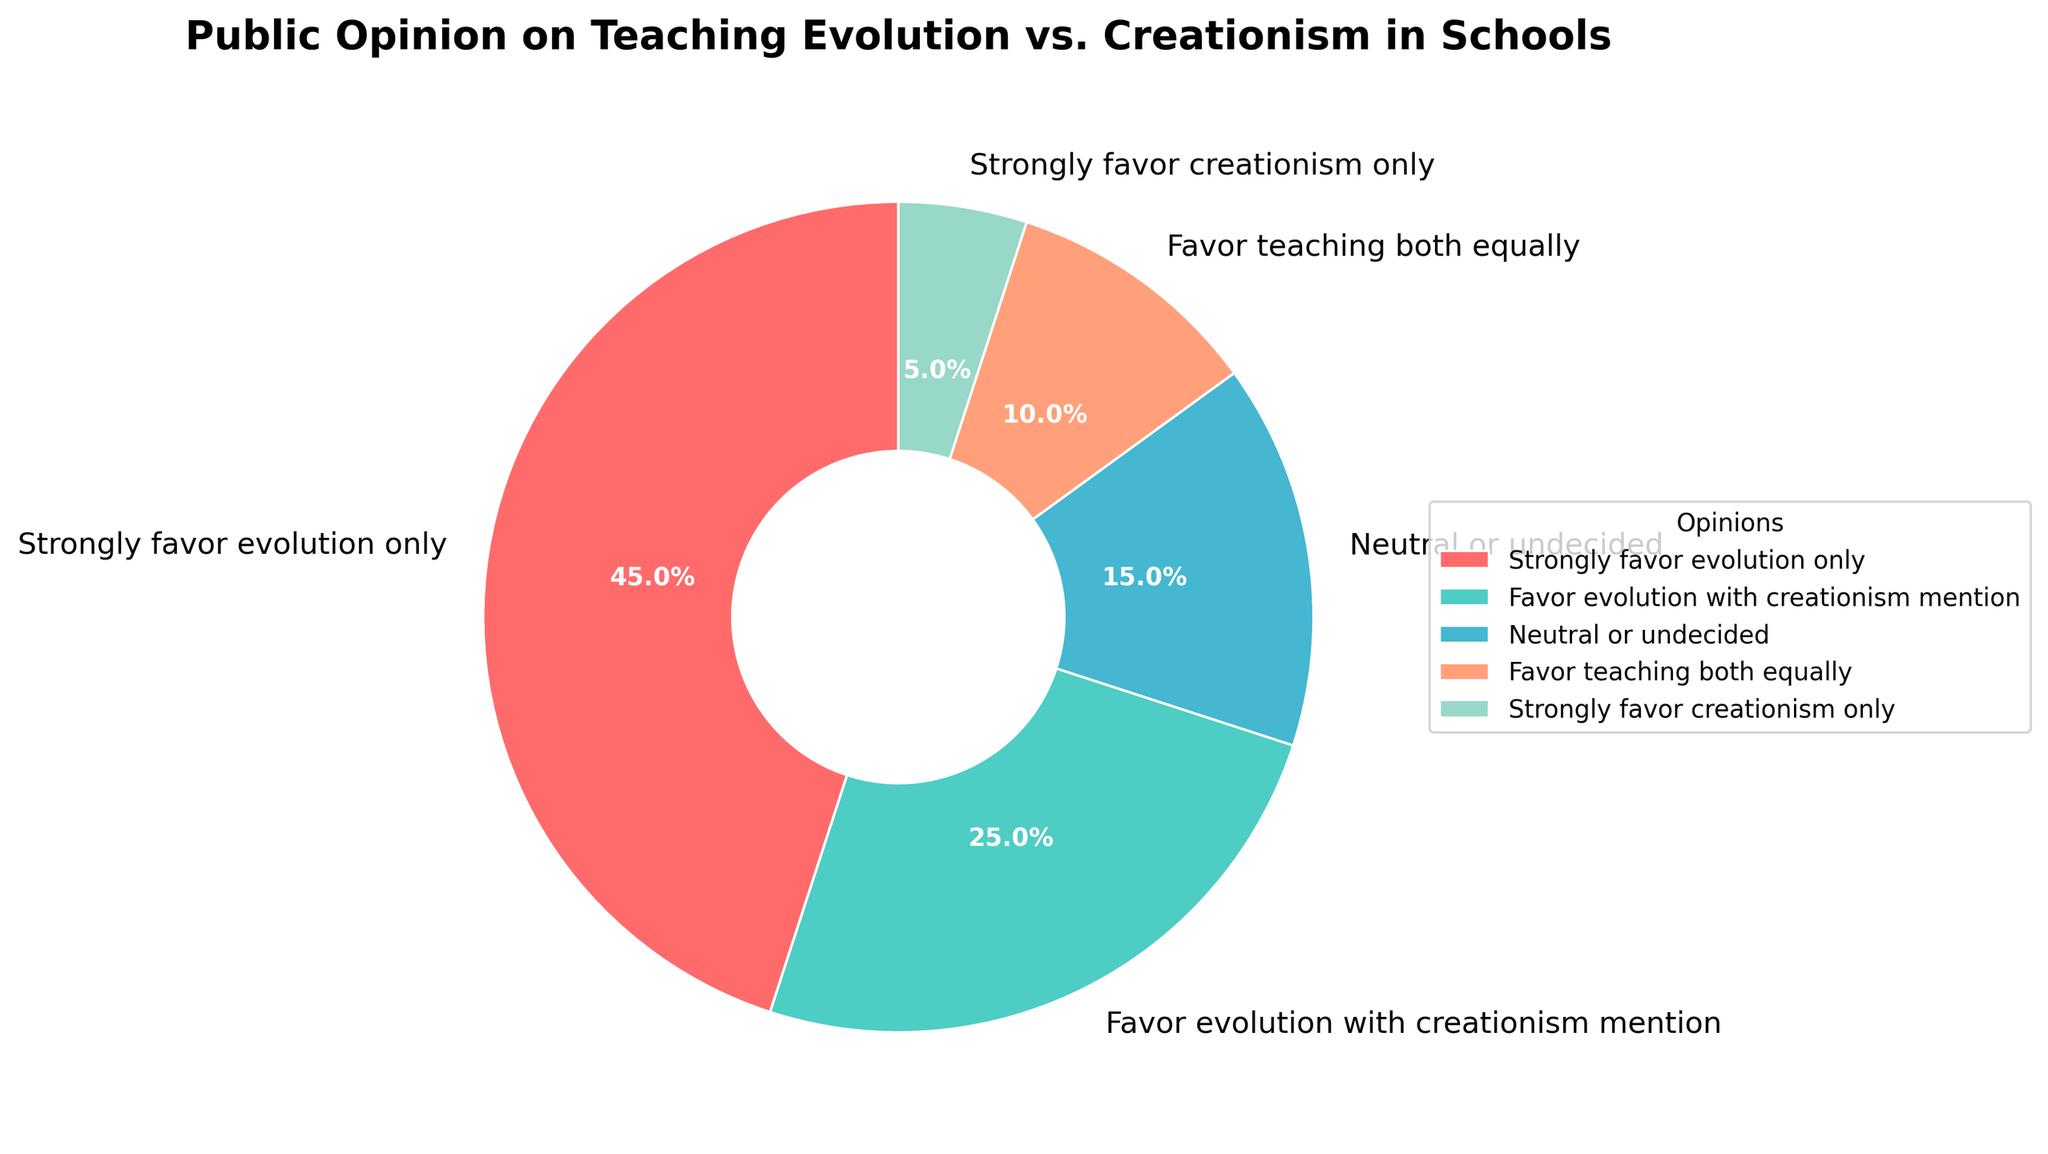What's the most strongly favored opinion on teaching evolution vs. creationism in schools? The slice representing "Strongly favor evolution only" is the largest in the pie chart, indicating it has the highest percentage.
Answer: Strongly favor evolution only Which opinions are least favored by the public? The pie chart shows that the smallest slice is "Strongly favor creationism only" at 5%.
Answer: Strongly favor creationism only What percentage favors both perspectives equally? Observing the chart, the slice labeled "Favor teaching both equally" is identified at 10%.
Answer: 10% What is the combined percentage of people who favor teaching evolution in some form (either only evolution or alongside creationism)? Combine the percentages of "Strongly favor evolution only" (45%) and "Favor evolution with creationism mention" (25%): 45% + 25% = 70%.
Answer: 70% How does the percentage of people who are neutral or undecided compare to those who favor teaching both equally? The pie chart shows "Neutral or undecided" is 15%, while "Favor teaching both equally" is 10%. Comparing the two, 15% is greater than 10%.
Answer: Neutral or undecided is greater What color represents the opinion 'Favor evolution with creationism mention'? Observing the colors, the "Favor evolution with creationism mention" slice is in teal/green.
Answer: Teal/Green How much larger is the percentage of people who strongly favor evolution only compared to those who strongly favor creationism only? Subtract the smaller percentage from the larger one: 45% (Strongly favor evolution only) - 5% (Strongly favor creationism only) = 40%.
Answer: 40% What percentage of people who have a definitive opinion (either strongly favor or favor) support teaching creationism in some fashion? Add the percentages of those who favor it alongside or only evolution: 10% (Favor teaching both equally) + 5% (Strongly favor creationism only) = 15%.
Answer: 15% What is the sum of percentages of people who are neutral or strongly favor creationism only? Sum the percentages of being neutral or favoring creationism only: 15% (Neutral or undecided) + 5% (Strongly favor creationism only) = 20%.
Answer: 20% 